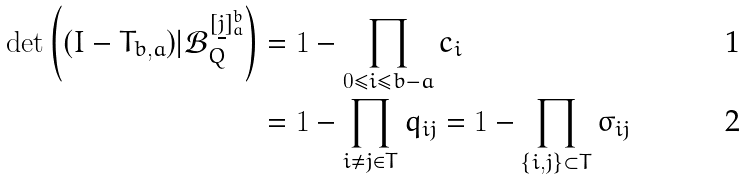<formula> <loc_0><loc_0><loc_500><loc_500>\det \left ( ( { I } - { T } _ { b , a } ) | { \mathcal { B } } _ { Q } ^ { [ \underline { j } ] _ { a } ^ { b } } \right ) & = 1 - \prod _ { 0 \leq i \leq b - a } c _ { i } \\ & = 1 - \prod _ { i \neq j \in T } q _ { i j } = 1 - \prod _ { \{ i , j \} \subset T } \sigma _ { i j }</formula> 